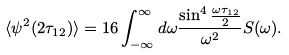Convert formula to latex. <formula><loc_0><loc_0><loc_500><loc_500>\langle \psi ^ { 2 } ( 2 \tau _ { 1 2 } ) \rangle = 1 6 \int _ { - \infty } ^ { \infty } d \omega \frac { \sin ^ { 4 } \frac { \omega \tau _ { 1 2 } } { 2 } } { \omega ^ { 2 } } S ( \omega ) .</formula> 